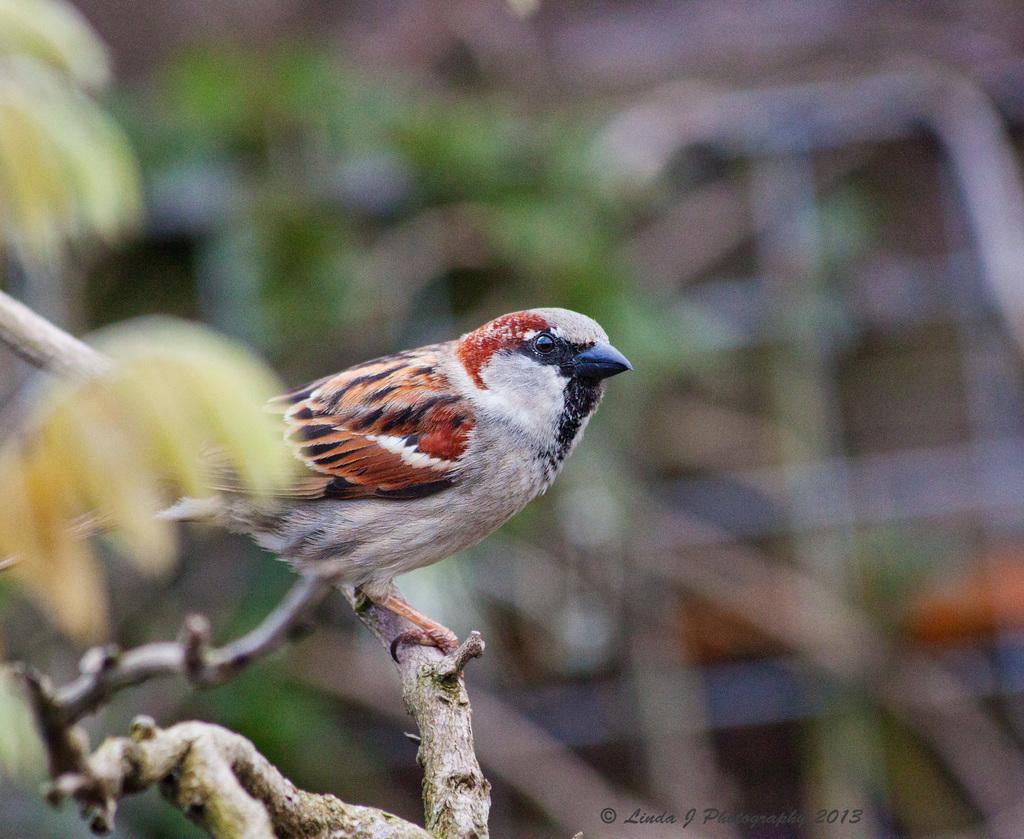In one or two sentences, can you explain what this image depicts? Here I can see a bird on a stem. It is looking at the right side. On the left side few leaves are visible. The background is blurred. At the bottom of this image I can see some edited text. 